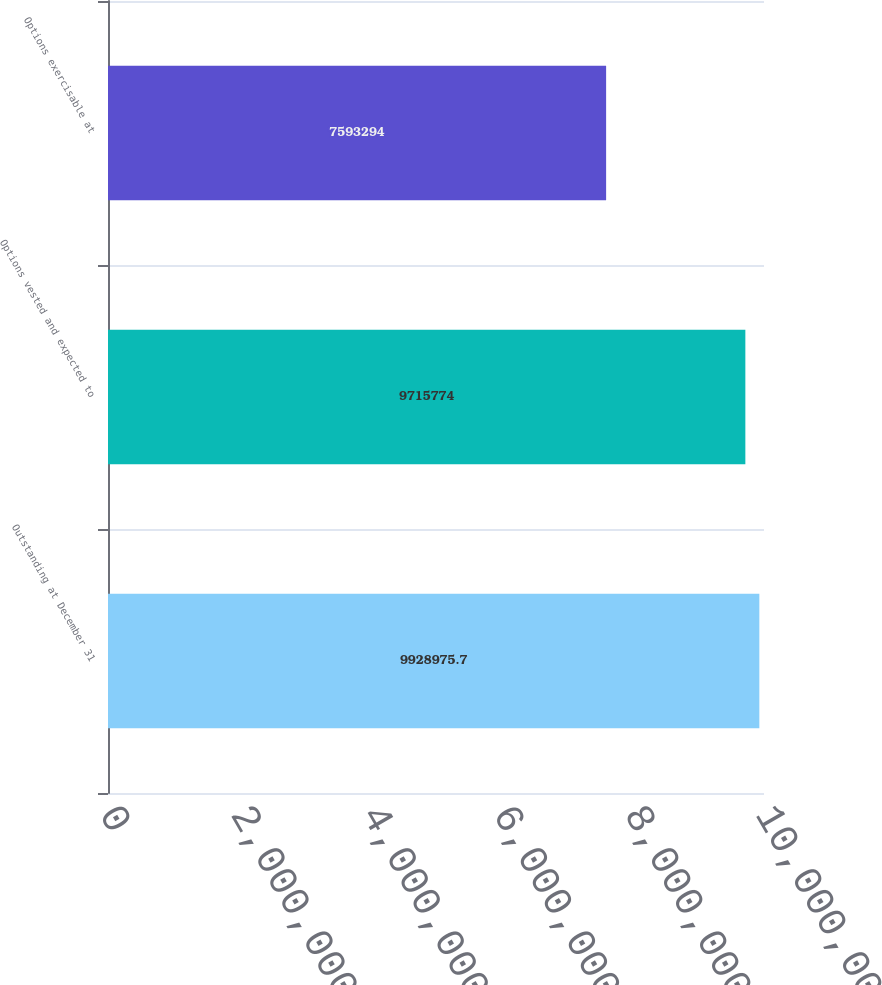Convert chart to OTSL. <chart><loc_0><loc_0><loc_500><loc_500><bar_chart><fcel>Outstanding at December 31<fcel>Options vested and expected to<fcel>Options exercisable at<nl><fcel>9.92898e+06<fcel>9.71577e+06<fcel>7.59329e+06<nl></chart> 